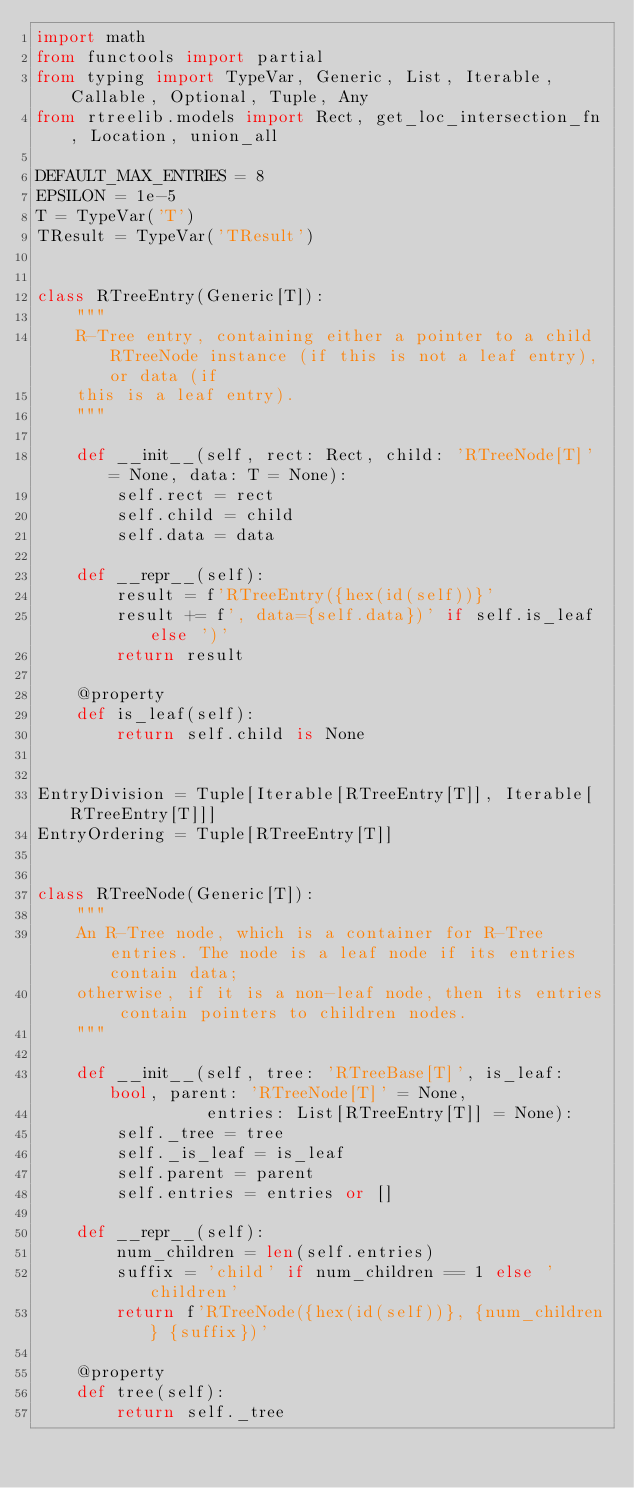Convert code to text. <code><loc_0><loc_0><loc_500><loc_500><_Python_>import math
from functools import partial
from typing import TypeVar, Generic, List, Iterable, Callable, Optional, Tuple, Any
from rtreelib.models import Rect, get_loc_intersection_fn, Location, union_all

DEFAULT_MAX_ENTRIES = 8
EPSILON = 1e-5
T = TypeVar('T')
TResult = TypeVar('TResult')


class RTreeEntry(Generic[T]):
    """
    R-Tree entry, containing either a pointer to a child RTreeNode instance (if this is not a leaf entry), or data (if
    this is a leaf entry).
    """

    def __init__(self, rect: Rect, child: 'RTreeNode[T]' = None, data: T = None):
        self.rect = rect
        self.child = child
        self.data = data

    def __repr__(self):
        result = f'RTreeEntry({hex(id(self))}'
        result += f', data={self.data})' if self.is_leaf else ')'
        return result

    @property
    def is_leaf(self):
        return self.child is None


EntryDivision = Tuple[Iterable[RTreeEntry[T]], Iterable[RTreeEntry[T]]]
EntryOrdering = Tuple[RTreeEntry[T]]


class RTreeNode(Generic[T]):
    """
    An R-Tree node, which is a container for R-Tree entries. The node is a leaf node if its entries contain data;
    otherwise, if it is a non-leaf node, then its entries contain pointers to children nodes.
    """

    def __init__(self, tree: 'RTreeBase[T]', is_leaf: bool, parent: 'RTreeNode[T]' = None,
                 entries: List[RTreeEntry[T]] = None):
        self._tree = tree
        self._is_leaf = is_leaf
        self.parent = parent
        self.entries = entries or []

    def __repr__(self):
        num_children = len(self.entries)
        suffix = 'child' if num_children == 1 else 'children'
        return f'RTreeNode({hex(id(self))}, {num_children} {suffix})'

    @property
    def tree(self):
        return self._tree
</code> 